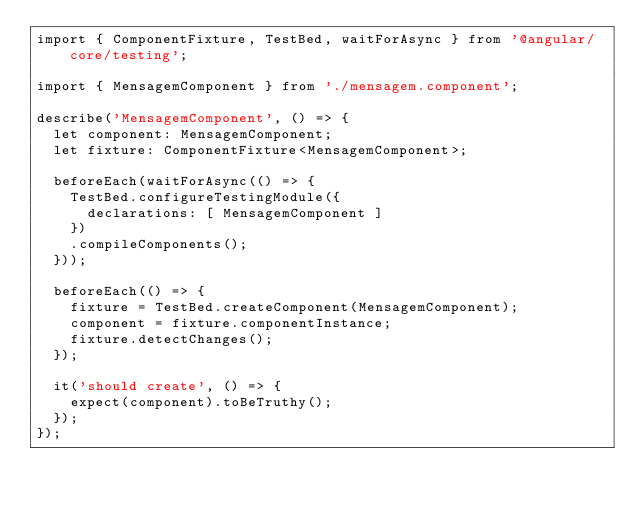<code> <loc_0><loc_0><loc_500><loc_500><_TypeScript_>import { ComponentFixture, TestBed, waitForAsync } from '@angular/core/testing';

import { MensagemComponent } from './mensagem.component';

describe('MensagemComponent', () => {
  let component: MensagemComponent;
  let fixture: ComponentFixture<MensagemComponent>;

  beforeEach(waitForAsync(() => {
    TestBed.configureTestingModule({
      declarations: [ MensagemComponent ]
    })
    .compileComponents();
  }));

  beforeEach(() => {
    fixture = TestBed.createComponent(MensagemComponent);
    component = fixture.componentInstance;
    fixture.detectChanges();
  });

  it('should create', () => {
    expect(component).toBeTruthy();
  });
});
</code> 